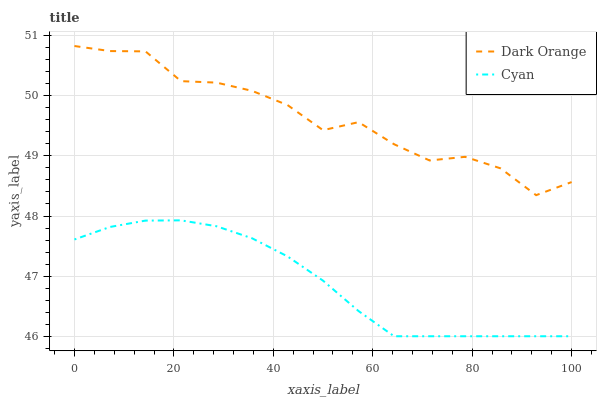Does Cyan have the minimum area under the curve?
Answer yes or no. Yes. Does Dark Orange have the maximum area under the curve?
Answer yes or no. Yes. Does Cyan have the maximum area under the curve?
Answer yes or no. No. Is Cyan the smoothest?
Answer yes or no. Yes. Is Dark Orange the roughest?
Answer yes or no. Yes. Is Cyan the roughest?
Answer yes or no. No. Does Cyan have the highest value?
Answer yes or no. No. Is Cyan less than Dark Orange?
Answer yes or no. Yes. Is Dark Orange greater than Cyan?
Answer yes or no. Yes. Does Cyan intersect Dark Orange?
Answer yes or no. No. 